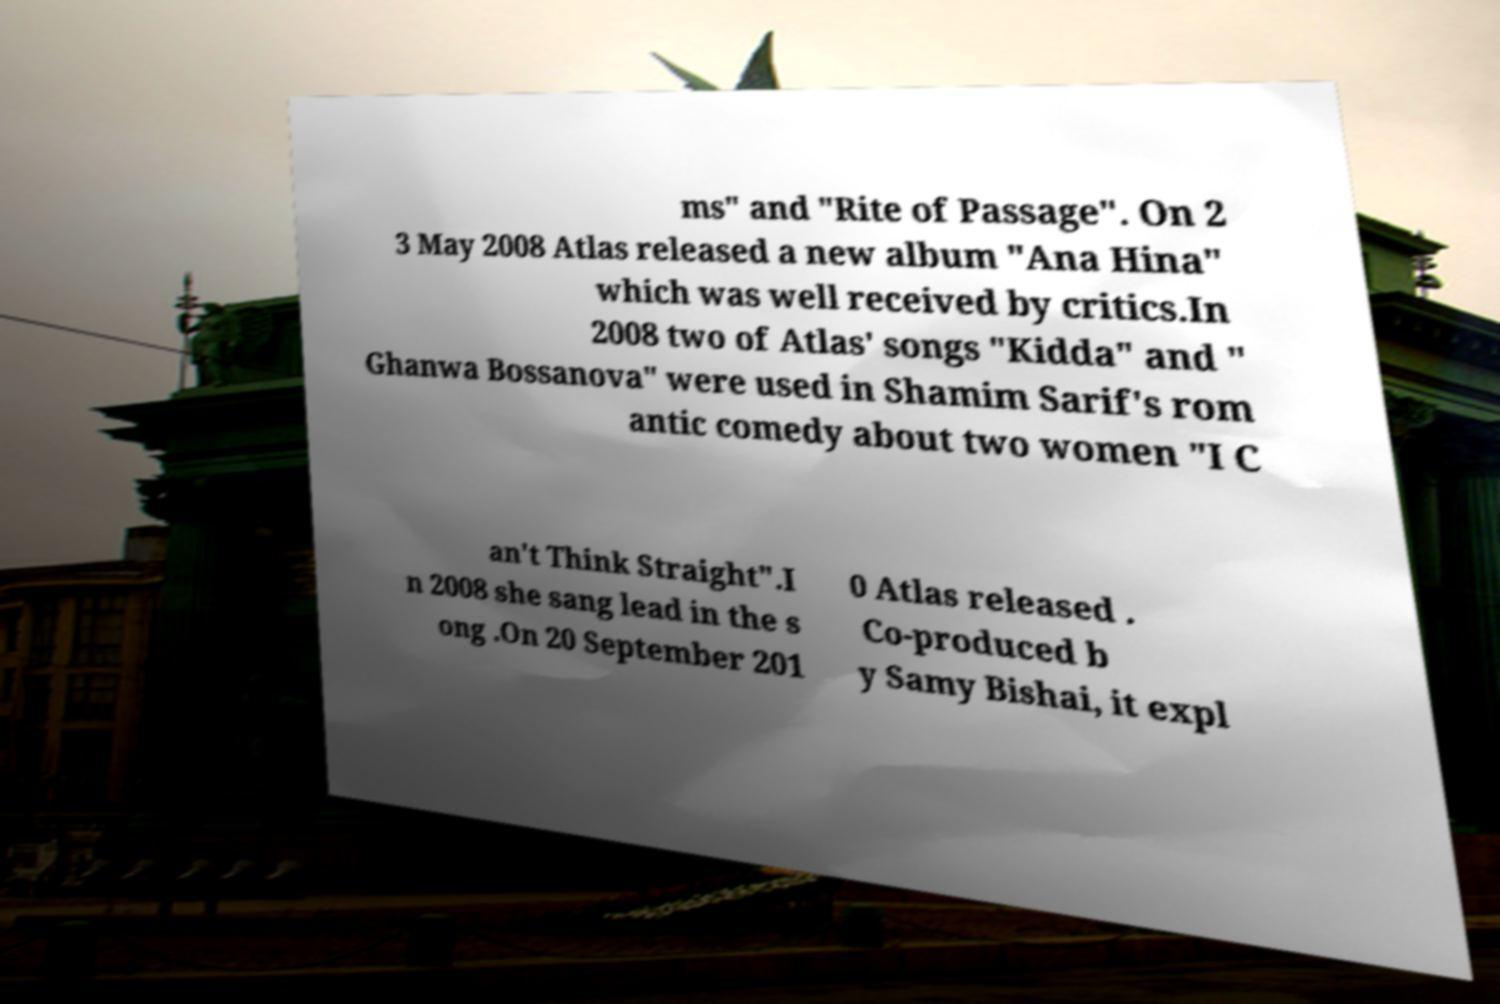Could you assist in decoding the text presented in this image and type it out clearly? ms" and "Rite of Passage". On 2 3 May 2008 Atlas released a new album "Ana Hina" which was well received by critics.In 2008 two of Atlas' songs "Kidda" and " Ghanwa Bossanova" were used in Shamim Sarif's rom antic comedy about two women "I C an't Think Straight".I n 2008 she sang lead in the s ong .On 20 September 201 0 Atlas released . Co-produced b y Samy Bishai, it expl 